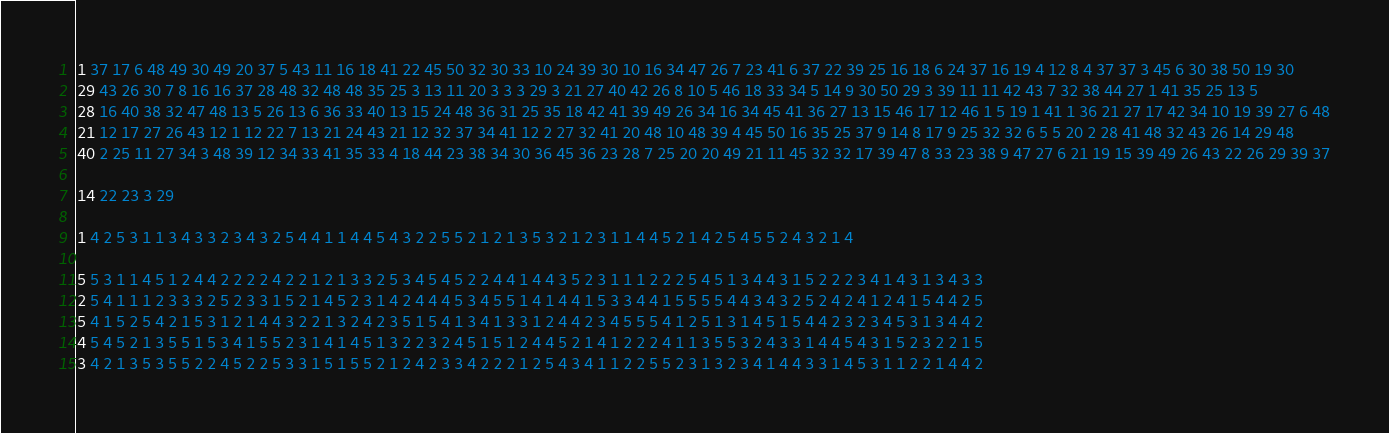Convert code to text. <code><loc_0><loc_0><loc_500><loc_500><_Matlab_>1 37 17 6 48 49 30 49 20 37 5 43 11 16 18 41 22 45 50 32 30 33 10 24 39 30 10 16 34 47 26 7 23 41 6 37 22 39 25 16 18 6 24 37 16 19 4 12 8 4 37 37 3 45 6 30 38 50 19 30
29 43 26 30 7 8 16 16 37 28 48 32 48 48 35 25 3 13 11 20 3 3 3 29 3 21 27 40 42 26 8 10 5 46 18 33 34 5 14 9 30 50 29 3 39 11 11 42 43 7 32 38 44 27 1 41 35 25 13 5
28 16 40 38 32 47 48 13 5 26 13 6 36 33 40 13 15 24 48 36 31 25 35 18 42 41 39 49 26 34 16 34 45 41 36 27 13 15 46 17 12 46 1 5 19 1 41 1 36 21 27 17 42 34 10 19 39 27 6 48
21 12 17 27 26 43 12 1 12 22 7 13 21 24 43 21 12 32 37 34 41 12 2 27 32 41 20 48 10 48 39 4 45 50 16 35 25 37 9 14 8 17 9 25 32 32 6 5 5 20 2 28 41 48 32 43 26 14 29 48
40 2 25 11 27 34 3 48 39 12 34 33 41 35 33 4 18 44 23 38 34 30 36 45 36 23 28 7 25 20 20 49 21 11 45 32 32 17 39 47 8 33 23 38 9 47 27 6 21 19 15 39 49 26 43 22 26 29 39 37

14 22 23 3 29

1 4 2 5 3 1 1 3 4 3 3 2 3 4 3 2 5 4 4 1 1 4 4 5 4 3 2 2 5 5 2 1 2 1 3 5 3 2 1 2 3 1 1 4 4 5 2 1 4 2 5 4 5 5 2 4 3 2 1 4

5 5 3 1 1 4 5 1 2 4 4 2 2 2 2 4 2 2 1 2 1 3 3 2 5 3 4 5 4 5 2 2 4 4 1 4 4 3 5 2 3 1 1 1 2 2 2 5 4 5 1 3 4 4 3 1 5 2 2 2 3 4 1 4 3 1 3 4 3 3
2 5 4 1 1 1 2 3 3 3 2 5 2 3 3 1 5 2 1 4 5 2 3 1 4 2 4 4 4 5 3 4 5 5 1 4 1 4 4 1 5 3 3 4 4 1 5 5 5 5 4 4 3 4 3 2 5 2 4 2 4 1 2 4 1 5 4 4 2 5
5 4 1 5 2 5 4 2 1 5 3 1 2 1 4 4 3 2 2 1 3 2 4 2 3 5 1 5 4 1 3 4 1 3 3 1 2 4 4 2 3 4 5 5 5 4 1 2 5 1 3 1 4 5 1 5 4 4 2 3 2 3 4 5 3 1 3 4 4 2
4 5 4 5 2 1 3 5 5 1 5 3 4 1 5 5 2 3 1 4 1 4 5 1 3 2 2 3 2 4 5 1 5 1 2 4 4 5 2 1 4 1 2 2 2 4 1 1 3 5 5 3 2 4 3 3 1 4 4 5 4 3 1 5 2 3 2 2 1 5
3 4 2 1 3 5 3 5 5 2 2 4 5 2 2 5 3 3 1 5 1 5 5 2 1 2 4 2 3 3 4 2 2 2 1 2 5 4 3 4 1 1 2 2 5 5 2 3 1 3 2 3 4 1 4 4 3 3 1 4 5 3 1 1 2 2 1 4 4 2</code> 